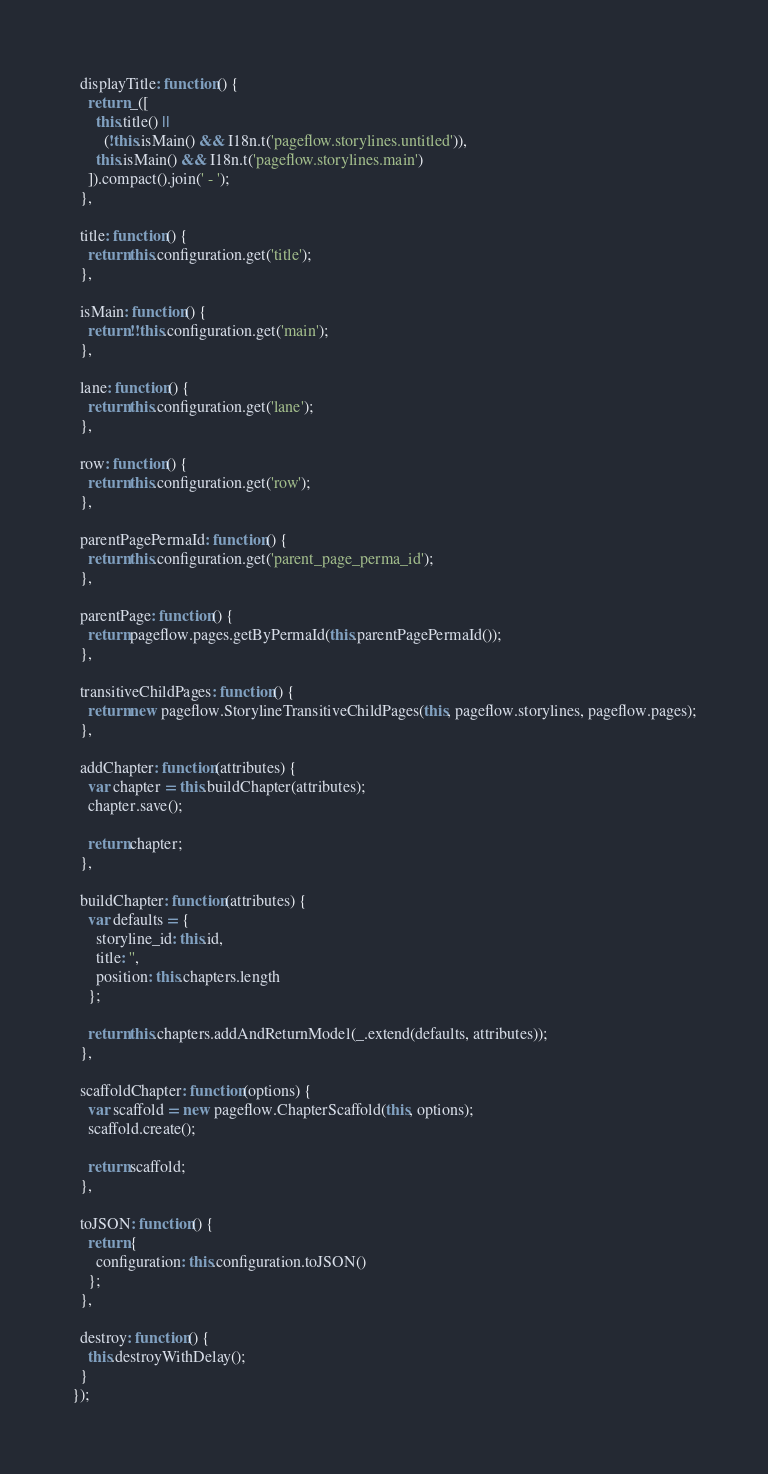<code> <loc_0><loc_0><loc_500><loc_500><_JavaScript_>
  displayTitle: function() {
    return _([
      this.title() ||
        (!this.isMain() && I18n.t('pageflow.storylines.untitled')),
      this.isMain() && I18n.t('pageflow.storylines.main')
    ]).compact().join(' - ');
  },

  title: function() {
    return this.configuration.get('title');
  },

  isMain: function() {
    return !!this.configuration.get('main');
  },

  lane: function() {
    return this.configuration.get('lane');
  },

  row: function() {
    return this.configuration.get('row');
  },

  parentPagePermaId: function() {
    return this.configuration.get('parent_page_perma_id');
  },

  parentPage: function() {
    return pageflow.pages.getByPermaId(this.parentPagePermaId());
  },

  transitiveChildPages: function() {
    return new pageflow.StorylineTransitiveChildPages(this, pageflow.storylines, pageflow.pages);
  },

  addChapter: function(attributes) {
    var chapter = this.buildChapter(attributes);
    chapter.save();

    return chapter;
  },

  buildChapter: function(attributes) {
    var defaults = {
      storyline_id: this.id,
      title: '',
      position: this.chapters.length
    };

    return this.chapters.addAndReturnModel(_.extend(defaults, attributes));
  },

  scaffoldChapter: function(options) {
    var scaffold = new pageflow.ChapterScaffold(this, options);
    scaffold.create();

    return scaffold;
  },

  toJSON: function() {
    return {
      configuration: this.configuration.toJSON()
    };
  },

  destroy: function() {
    this.destroyWithDelay();
  }
});</code> 